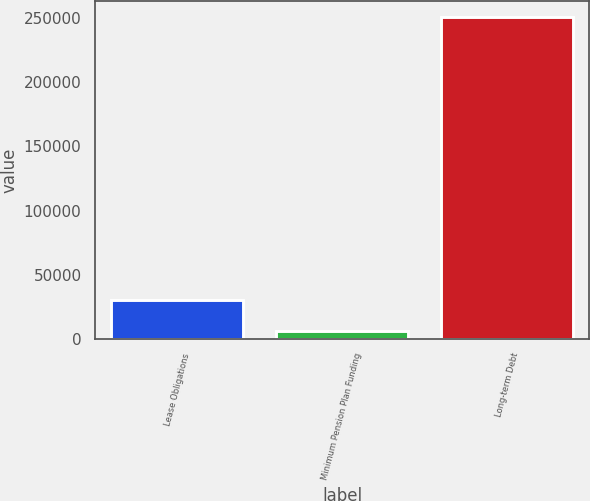Convert chart to OTSL. <chart><loc_0><loc_0><loc_500><loc_500><bar_chart><fcel>Lease Obligations<fcel>Minimum Pension Plan Funding<fcel>Long-term Debt<nl><fcel>30170.4<fcel>5650<fcel>250854<nl></chart> 